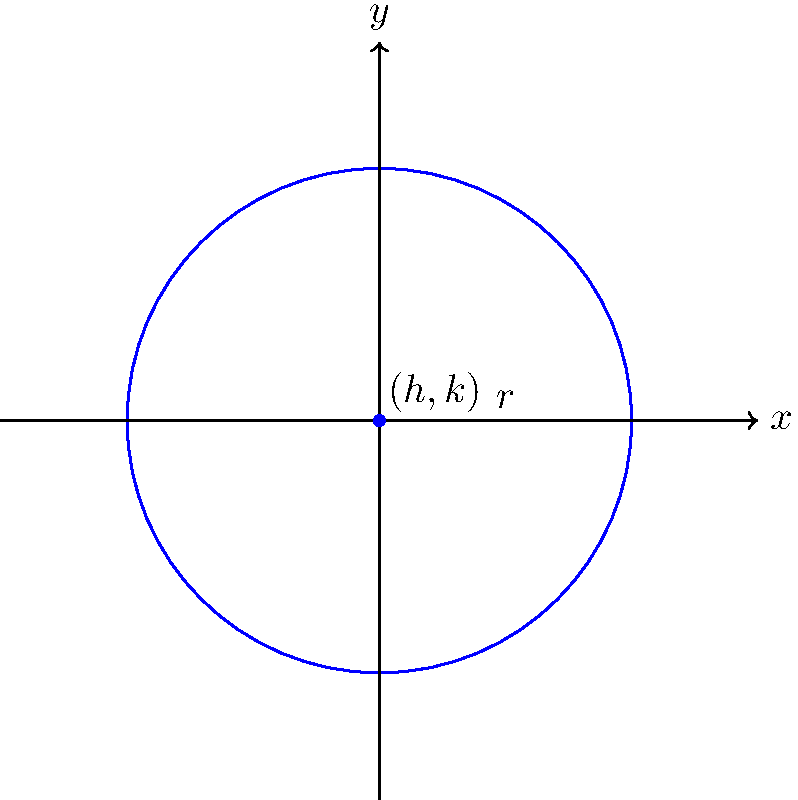In the spirit of our neighborhood's love for shapes, let's explore a special circle together. We have a circle described by the equation $$(x-2)^2 + (y+1)^2 = 16$$

Can you help me find the center and radius of this circle? Remember, just like how we're at the center of our TV community, every circle has a special center too! Let's approach this step-by-step, just like we do when we're learning something new in our neighborhood:

1) The general form of a circle equation is:
   $$(x-h)^2 + (y-k)^2 = r^2$$
   where $(h,k)$ is the center and $r$ is the radius.

2) Our equation is $$(x-2)^2 + (y+1)^2 = 16$$

3) Comparing our equation to the general form:
   - We see $(x-2)^2$, so $h=2$
   - We see $(y+1)^2$, which is equivalent to $(y-(-1))^2$, so $k=-1$
   - The right side is 16, which means $r^2 = 16$

4) To find $r$, we need to take the square root of both sides:
   $r = \sqrt{16} = 4$

5) Therefore, the center is $(2,-1)$ and the radius is 4.

Just like how we're always at the heart of our show, the point $(2,-1)$ is at the heart of this circle, and it reaches out 4 units in every direction, just like how we reach out to all our neighbors!
Answer: Center: $(2,-1)$, Radius: $4$ 